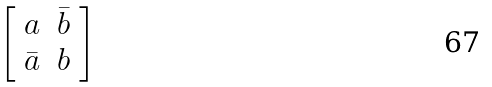Convert formula to latex. <formula><loc_0><loc_0><loc_500><loc_500>\left [ \begin{array} { c c } a & \bar { b } \\ \bar { a } & b \end{array} \right ]</formula> 